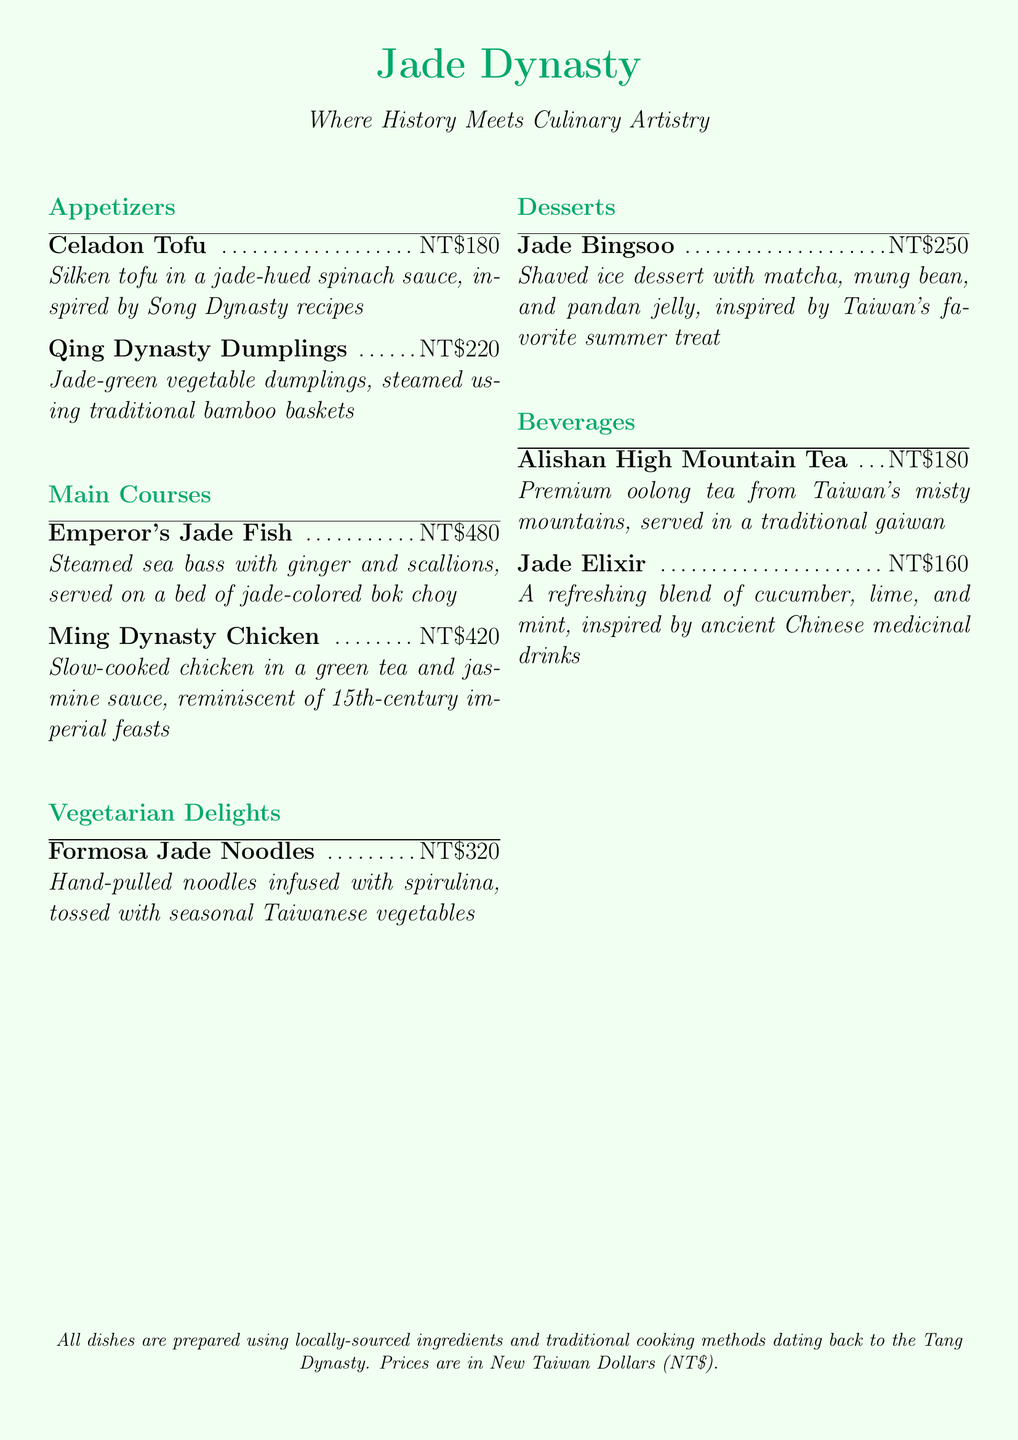What is the price of Celadon Tofu? The price of Celadon Tofu is listed in the document as NT$180.
Answer: NT$180 What type of tea is served at Jade Dynasty? The document mentions Alishan High Mountain Tea, which is a specific type of oolong tea from Taiwan.
Answer: Alishan High Mountain Tea Which dish is inspired by Song Dynasty recipes? The document specifies that Celadon Tofu is inspired by Song Dynasty recipes.
Answer: Celadon Tofu How many different sections are in the menu? The document outlines five sections: Appetizers, Main Courses, Vegetarian Delights, Desserts, and Beverages.
Answer: Five What color is associated with the restaurant's theme? The color used throughout the menu and associated with the restaurant's theme is jade green.
Answer: Jade green Which dish features matcha as an ingredient? Jade Bingsoo is the dessert that includes matcha, as stated in the description.
Answer: Jade Bingsoo What is the main ingredient of the Emperor's Jade Fish? The primary ingredient for the Emperor's Jade Fish is sea bass, as indicated in the menu description.
Answer: Sea bass What cooking technique is highlighted in the preparation of Qing Dynasty Dumplings? The dumplings are steamed, which is a traditional cooking technique mentioned in the description.
Answer: Steamed How much do the Ming Dynasty Chicken and Emperor's Jade Fish cost combined? The total cost of both dishes is NT$420 (Ming Dynasty Chicken) + NT$480 (Emperor's Jade Fish) = NT$900.
Answer: NT$900 